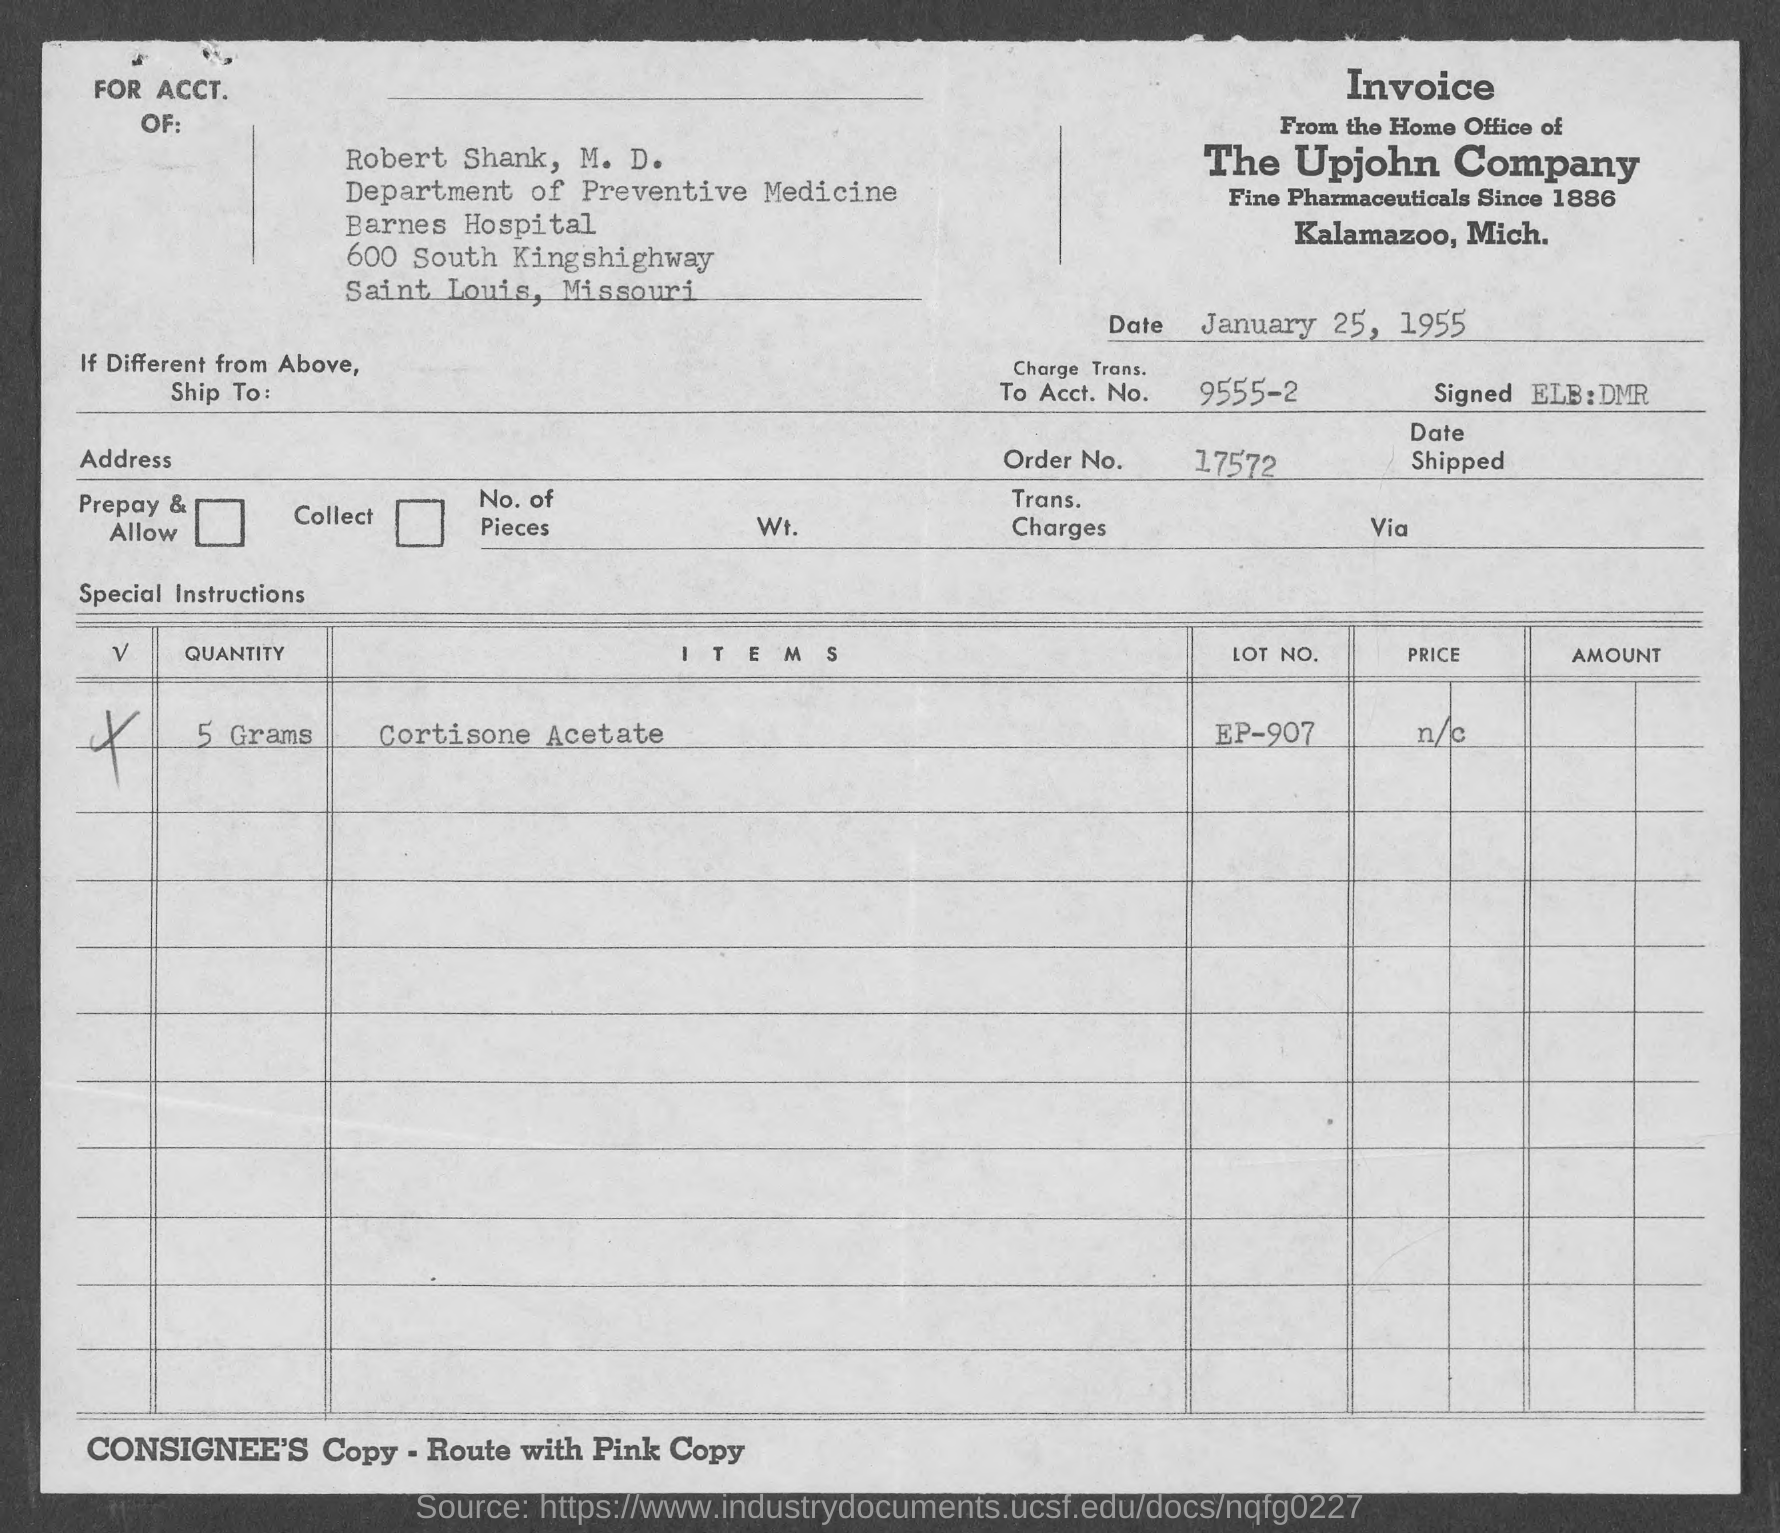Outline some significant characteristics in this image. The document is dated January 25, 1955. The item in question is Cortisone Acetate. The order number is 17572. The LOT NO. is EP-907. The quantity specified is 5 Grams. 